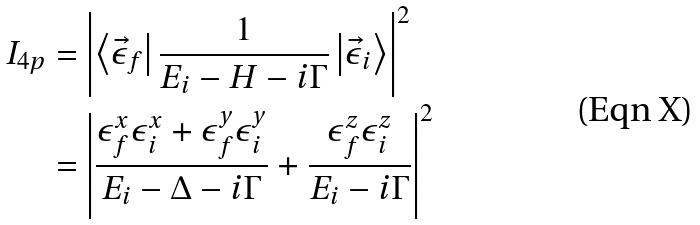<formula> <loc_0><loc_0><loc_500><loc_500>I _ { 4 p } & = \left | \left \langle \vec { \epsilon } _ { f } \right | \frac { 1 } { E _ { i } - H - i \Gamma } \left | \vec { \epsilon } _ { i } \right \rangle \right | ^ { 2 } \\ & = \left | \frac { \epsilon _ { f } ^ { x } \epsilon _ { i } ^ { x } + \epsilon _ { f } ^ { y } \epsilon _ { i } ^ { y } } { E _ { i } - \Delta - i \Gamma } + \frac { \epsilon _ { f } ^ { z } \epsilon _ { i } ^ { z } } { E _ { i } - i \Gamma } \right | ^ { 2 }</formula> 